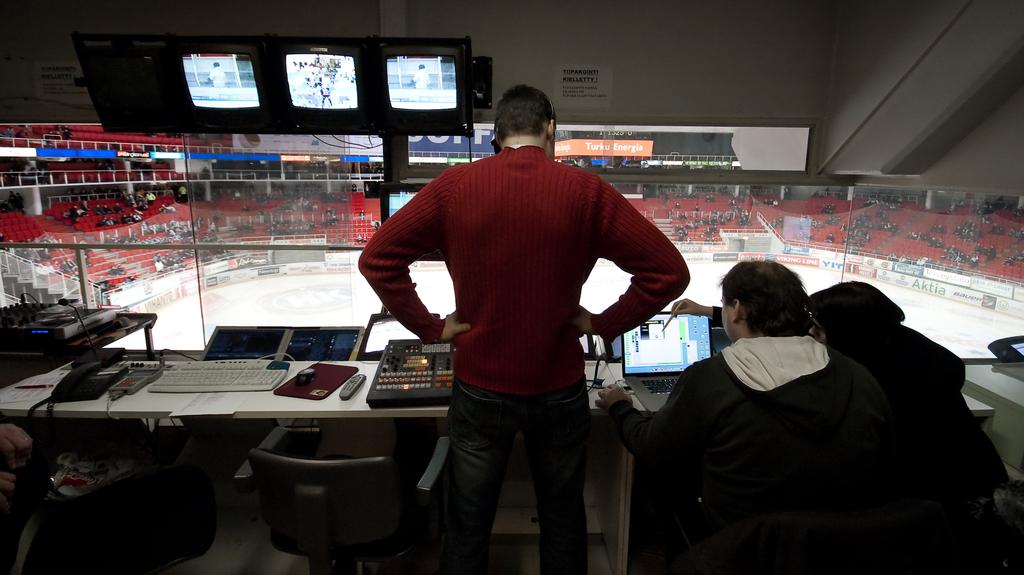What type of structure is visible in the image? There is a stadium in the image. How many people are present in the image? There are three people in the image. What objects can be seen on the table in the image? There is a keyboard, a telephone, a remote, and a screen on the table in the image. What type of yam is being used as a paperweight on the table in the image? There is no yam present in the image; the table only contains a keyboard, a telephone, a remote, and a screen. 